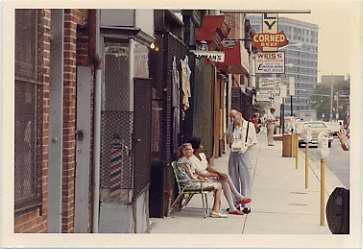Is this photo in color?
Quick response, please. Yes. How many people are sitting down on chairs?
Concise answer only. 2. Is it raining?
Concise answer only. No. How do you know this photo was taken long ago?
Short answer required. Color. Is the picture in color or b/w?
Short answer required. Color. How is the man keeping his pants up?
Write a very short answer. Suspenders. Is the man's face green?
Quick response, please. No. What city is it?
Concise answer only. Chicago. Is the photo colored?
Concise answer only. Yes. What sort of buildings line the street?
Give a very brief answer. Stores. What gas station can you see?
Answer briefly. 0. What this picture taken recently?
Quick response, please. No. Is the photo in color?
Keep it brief. Yes. 